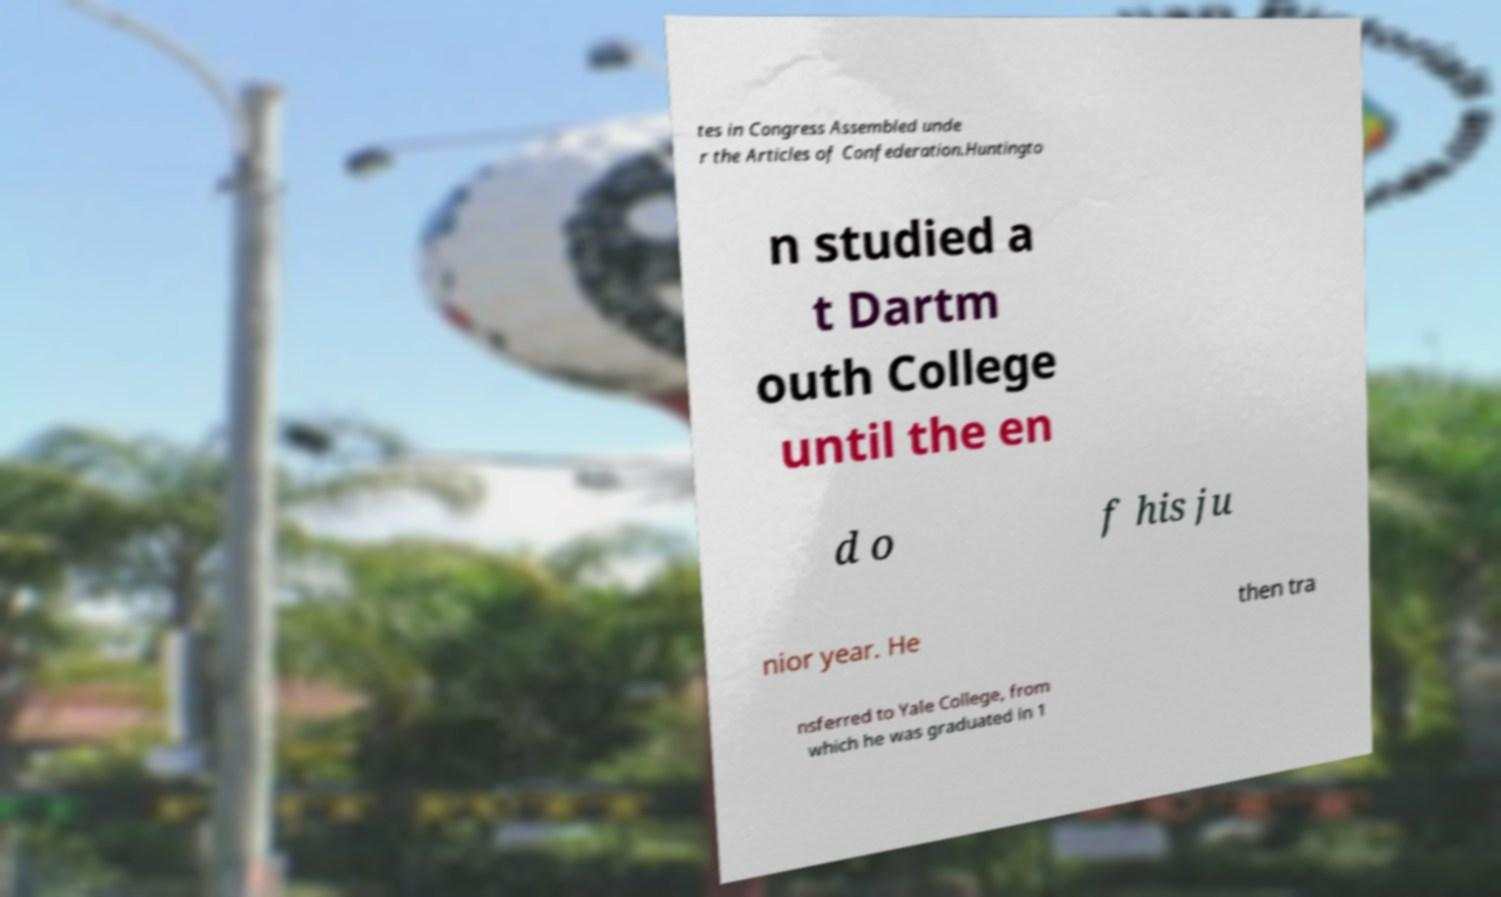Please identify and transcribe the text found in this image. tes in Congress Assembled unde r the Articles of Confederation.Huntingto n studied a t Dartm outh College until the en d o f his ju nior year. He then tra nsferred to Yale College, from which he was graduated in 1 